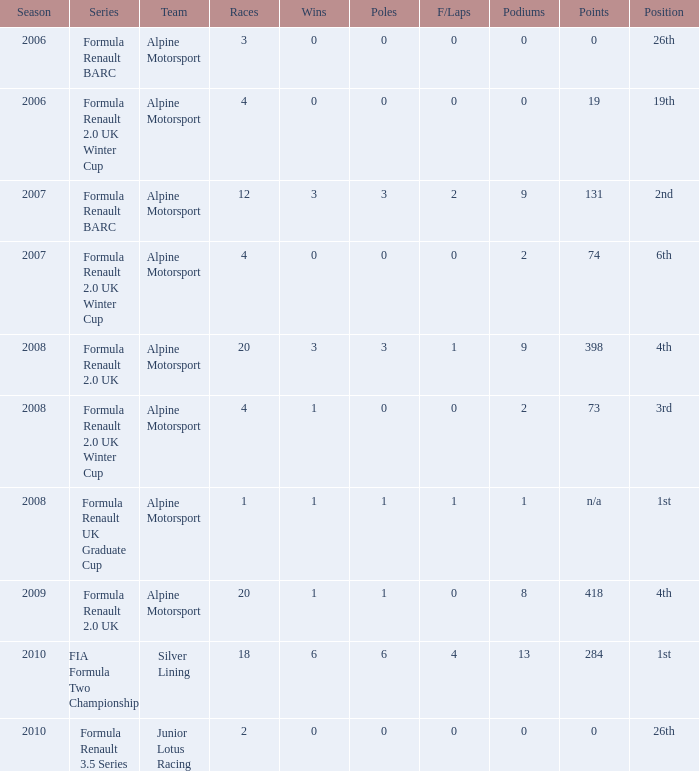How much were the f/laps if poles is higher than 1.0 during 2008? 1.0. 